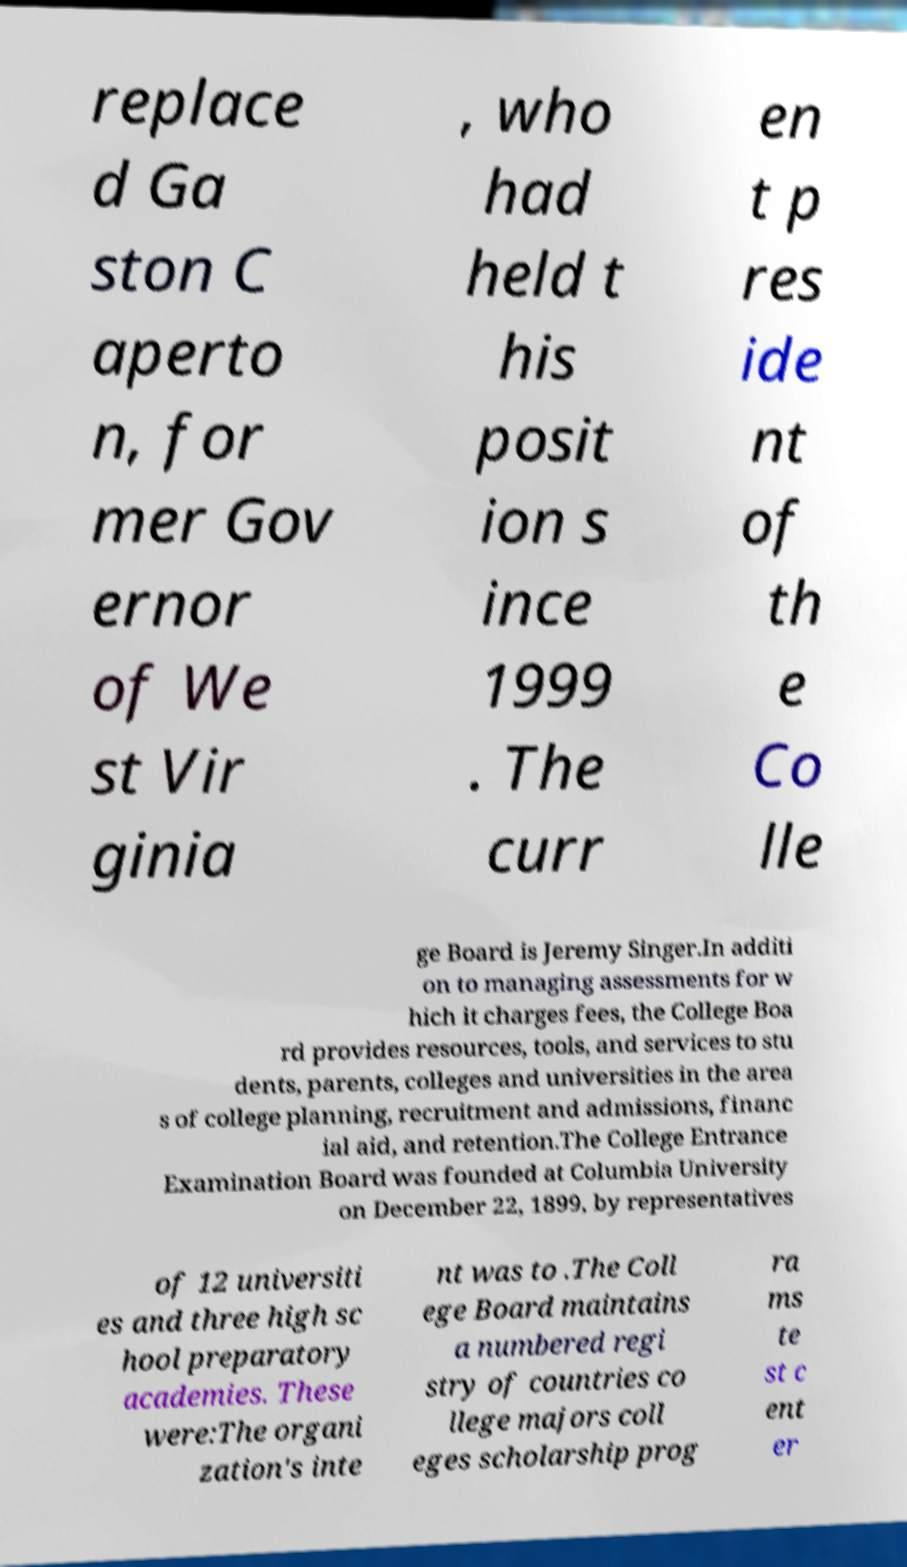There's text embedded in this image that I need extracted. Can you transcribe it verbatim? replace d Ga ston C aperto n, for mer Gov ernor of We st Vir ginia , who had held t his posit ion s ince 1999 . The curr en t p res ide nt of th e Co lle ge Board is Jeremy Singer.In additi on to managing assessments for w hich it charges fees, the College Boa rd provides resources, tools, and services to stu dents, parents, colleges and universities in the area s of college planning, recruitment and admissions, financ ial aid, and retention.The College Entrance Examination Board was founded at Columbia University on December 22, 1899, by representatives of 12 universiti es and three high sc hool preparatory academies. These were:The organi zation's inte nt was to .The Coll ege Board maintains a numbered regi stry of countries co llege majors coll eges scholarship prog ra ms te st c ent er 